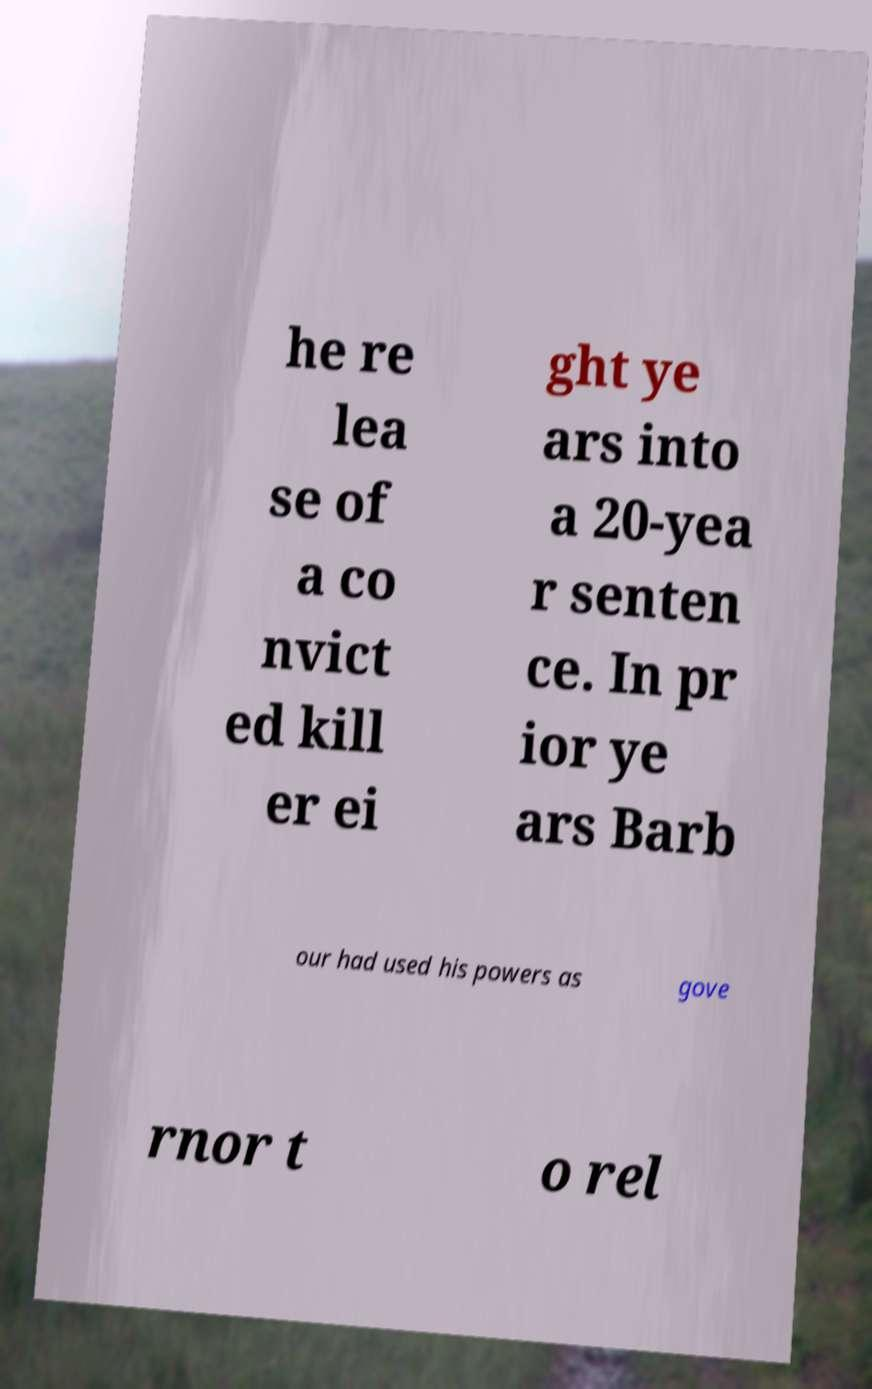Can you read and provide the text displayed in the image?This photo seems to have some interesting text. Can you extract and type it out for me? he re lea se of a co nvict ed kill er ei ght ye ars into a 20-yea r senten ce. In pr ior ye ars Barb our had used his powers as gove rnor t o rel 